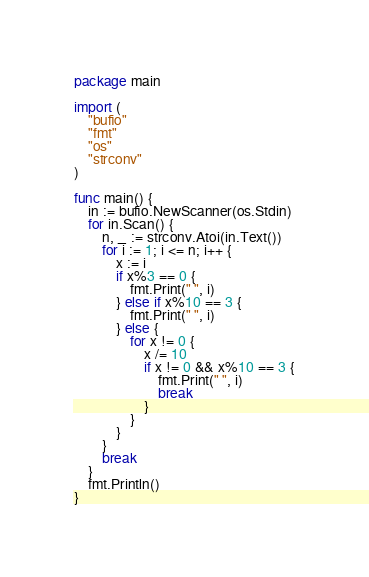Convert code to text. <code><loc_0><loc_0><loc_500><loc_500><_Go_>package main

import (
	"bufio"
	"fmt"
	"os"
	"strconv"
)

func main() {
	in := bufio.NewScanner(os.Stdin)
	for in.Scan() {
		n, _ := strconv.Atoi(in.Text())
		for i := 1; i <= n; i++ {
			x := i
			if x%3 == 0 {
				fmt.Print(" ", i)
			} else if x%10 == 3 {
				fmt.Print(" ", i)
			} else {
				for x != 0 {
					x /= 10
					if x != 0 && x%10 == 3 {
						fmt.Print(" ", i)
						break
					}
				}
			}
		}
		break
	}
	fmt.Println()
}

</code> 